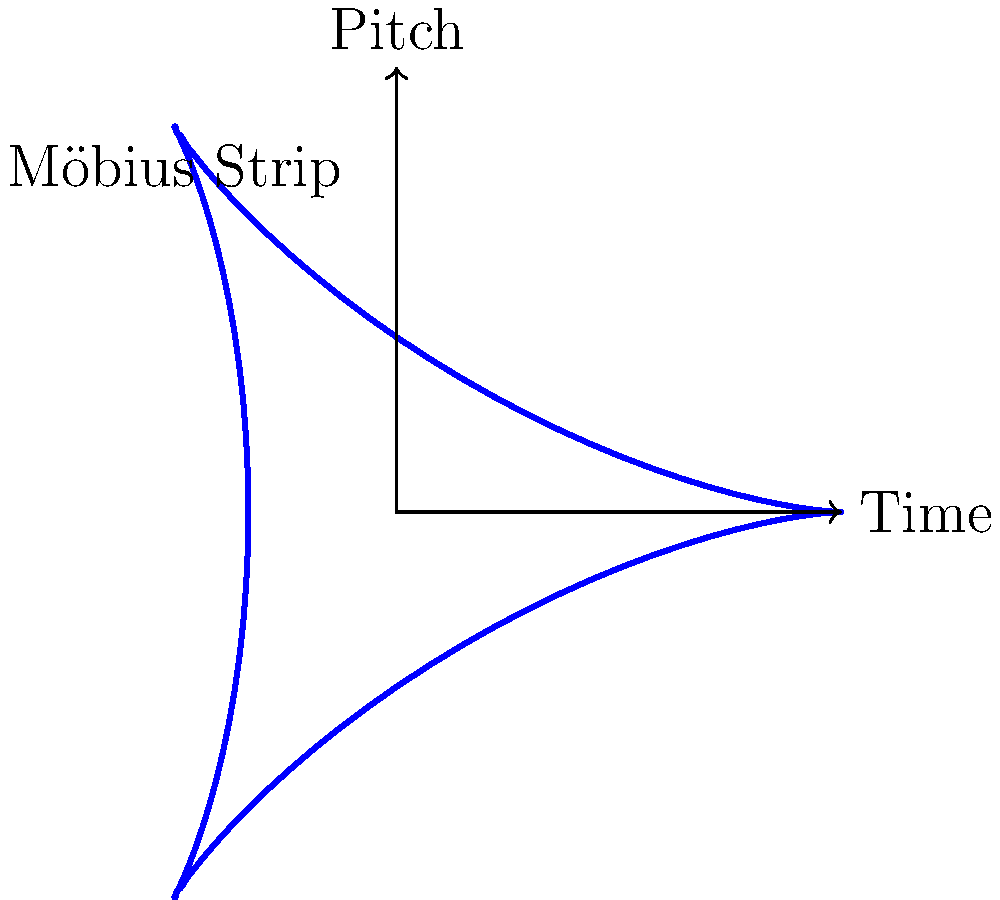In the context of looping musical sequences, how does the topology of a Möbius strip relate to the concept of seamless repetition in U2's ambient tracks? Consider the diagram showing a Möbius strip representation of pitch over time. To understand the relationship between Möbius strips and looping musical sequences, let's follow these steps:

1. Möbius Strip Properties:
   - A Möbius strip is a surface with only one side and one edge.
   - It has the mathematical property of being non-orientable.

2. Musical Loop Representation:
   - In the diagram, the horizontal axis represents time, and the vertical axis represents pitch.
   - The blue curve represents a musical sequence that loops seamlessly.

3. Seamless Repetition:
   - As you travel along the Möbius strip (following the blue curve), you eventually return to the starting point without discontinuity.
   - This mirrors how a well-crafted looping sequence in music returns to its beginning smoothly.

4. Pitch Inversion:
   - Notice that the strip twists, causing the pitch axis to invert.
   - This can represent how certain U2 ambient tracks might use pitch inversion techniques within their loops.

5. Infinite Loop:
   - The Möbius strip's single surface allows for continuous travel, symbolizing the infinite nature of a perfect loop.
   - This relates to how ambient tracks can be designed to loop indefinitely without a noticeable start or end point.

6. Non-orientability in Music:
   - The non-orientable property of the Möbius strip can be likened to how a well-crafted loop blurs the distinction between the beginning and end of a sequence.
   - This is often used in U2's ambient works to create a sense of timelessness or continuity.

7. Topological Transformation:
   - The twisting of the strip represents how musical elements can be transformed (e.g., reversed, inverted) while maintaining the loop's integrity.
   - This concept is often employed in U2's experimental and ambient pieces to create complex, evolving soundscapes.

In essence, the Möbius strip serves as a powerful metaphor for the structure of seamless, looping musical sequences, particularly relevant to the ambient and experimental aspects of U2's music.
Answer: Continuous, seamless looping with potential for pitch inversion and topological transformation 